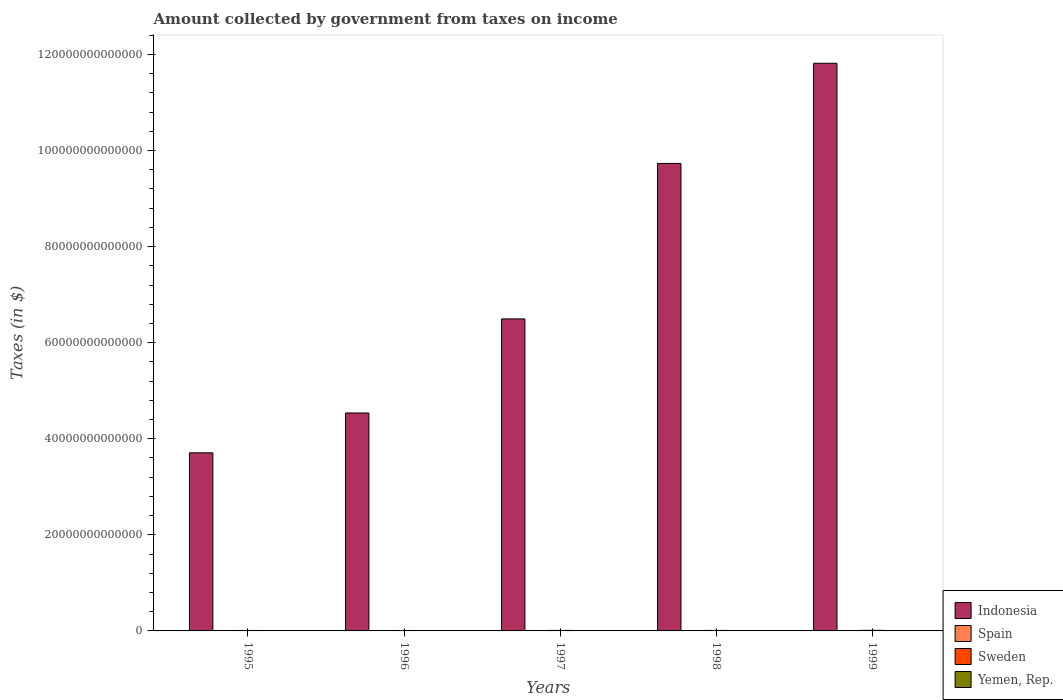How many different coloured bars are there?
Offer a very short reply. 4. Are the number of bars per tick equal to the number of legend labels?
Provide a succinct answer. Yes. In how many cases, is the number of bars for a given year not equal to the number of legend labels?
Give a very brief answer. 0. What is the amount collected by government from taxes on income in Sweden in 1997?
Offer a terse response. 1.04e+11. Across all years, what is the maximum amount collected by government from taxes on income in Indonesia?
Make the answer very short. 1.18e+14. Across all years, what is the minimum amount collected by government from taxes on income in Sweden?
Provide a short and direct response. 8.81e+1. In which year was the amount collected by government from taxes on income in Yemen, Rep. maximum?
Offer a terse response. 1998. What is the total amount collected by government from taxes on income in Sweden in the graph?
Keep it short and to the point. 5.17e+11. What is the difference between the amount collected by government from taxes on income in Indonesia in 1996 and that in 1999?
Give a very brief answer. -7.28e+13. What is the difference between the amount collected by government from taxes on income in Indonesia in 1998 and the amount collected by government from taxes on income in Sweden in 1996?
Your answer should be very brief. 9.72e+13. What is the average amount collected by government from taxes on income in Spain per year?
Keep it short and to the point. 4.33e+1. In the year 1999, what is the difference between the amount collected by government from taxes on income in Sweden and amount collected by government from taxes on income in Yemen, Rep.?
Ensure brevity in your answer.  7.61e+1. In how many years, is the amount collected by government from taxes on income in Spain greater than 120000000000000 $?
Offer a terse response. 0. What is the ratio of the amount collected by government from taxes on income in Indonesia in 1995 to that in 1998?
Make the answer very short. 0.38. Is the amount collected by government from taxes on income in Spain in 1995 less than that in 1997?
Offer a terse response. Yes. Is the difference between the amount collected by government from taxes on income in Sweden in 1995 and 1999 greater than the difference between the amount collected by government from taxes on income in Yemen, Rep. in 1995 and 1999?
Provide a succinct answer. Yes. What is the difference between the highest and the second highest amount collected by government from taxes on income in Indonesia?
Offer a terse response. 2.09e+13. What is the difference between the highest and the lowest amount collected by government from taxes on income in Indonesia?
Ensure brevity in your answer.  8.11e+13. Is it the case that in every year, the sum of the amount collected by government from taxes on income in Yemen, Rep. and amount collected by government from taxes on income in Sweden is greater than the sum of amount collected by government from taxes on income in Indonesia and amount collected by government from taxes on income in Spain?
Provide a succinct answer. Yes. What does the 1st bar from the left in 1997 represents?
Ensure brevity in your answer.  Indonesia. What does the 3rd bar from the right in 1995 represents?
Give a very brief answer. Spain. Is it the case that in every year, the sum of the amount collected by government from taxes on income in Indonesia and amount collected by government from taxes on income in Sweden is greater than the amount collected by government from taxes on income in Yemen, Rep.?
Keep it short and to the point. Yes. How many years are there in the graph?
Provide a short and direct response. 5. What is the difference between two consecutive major ticks on the Y-axis?
Provide a short and direct response. 2.00e+13. Are the values on the major ticks of Y-axis written in scientific E-notation?
Your answer should be compact. No. Does the graph contain any zero values?
Your answer should be very brief. No. Does the graph contain grids?
Ensure brevity in your answer.  No. Where does the legend appear in the graph?
Offer a terse response. Bottom right. How are the legend labels stacked?
Ensure brevity in your answer.  Vertical. What is the title of the graph?
Provide a short and direct response. Amount collected by government from taxes on income. Does "Puerto Rico" appear as one of the legend labels in the graph?
Your response must be concise. No. What is the label or title of the X-axis?
Make the answer very short. Years. What is the label or title of the Y-axis?
Give a very brief answer. Taxes (in $). What is the Taxes (in $) of Indonesia in 1995?
Your response must be concise. 3.71e+13. What is the Taxes (in $) in Spain in 1995?
Make the answer very short. 3.98e+1. What is the Taxes (in $) in Sweden in 1995?
Offer a terse response. 9.24e+1. What is the Taxes (in $) of Yemen, Rep. in 1995?
Offer a very short reply. 1.56e+1. What is the Taxes (in $) in Indonesia in 1996?
Offer a terse response. 4.54e+13. What is the Taxes (in $) of Spain in 1996?
Give a very brief answer. 4.36e+1. What is the Taxes (in $) in Sweden in 1996?
Your answer should be very brief. 8.81e+1. What is the Taxes (in $) of Yemen, Rep. in 1996?
Keep it short and to the point. 3.53e+1. What is the Taxes (in $) of Indonesia in 1997?
Keep it short and to the point. 6.49e+13. What is the Taxes (in $) of Spain in 1997?
Give a very brief answer. 4.23e+1. What is the Taxes (in $) of Sweden in 1997?
Provide a short and direct response. 1.04e+11. What is the Taxes (in $) in Yemen, Rep. in 1997?
Your answer should be very brief. 4.56e+1. What is the Taxes (in $) of Indonesia in 1998?
Keep it short and to the point. 9.73e+13. What is the Taxes (in $) of Spain in 1998?
Offer a terse response. 4.42e+1. What is the Taxes (in $) in Sweden in 1998?
Your answer should be very brief. 1.06e+11. What is the Taxes (in $) in Yemen, Rep. in 1998?
Give a very brief answer. 5.44e+1. What is the Taxes (in $) in Indonesia in 1999?
Offer a terse response. 1.18e+14. What is the Taxes (in $) of Spain in 1999?
Provide a short and direct response. 4.67e+1. What is the Taxes (in $) of Sweden in 1999?
Make the answer very short. 1.26e+11. What is the Taxes (in $) of Yemen, Rep. in 1999?
Offer a terse response. 5.02e+1. Across all years, what is the maximum Taxes (in $) of Indonesia?
Your answer should be very brief. 1.18e+14. Across all years, what is the maximum Taxes (in $) in Spain?
Your answer should be compact. 4.67e+1. Across all years, what is the maximum Taxes (in $) in Sweden?
Give a very brief answer. 1.26e+11. Across all years, what is the maximum Taxes (in $) in Yemen, Rep.?
Your response must be concise. 5.44e+1. Across all years, what is the minimum Taxes (in $) of Indonesia?
Your response must be concise. 3.71e+13. Across all years, what is the minimum Taxes (in $) of Spain?
Ensure brevity in your answer.  3.98e+1. Across all years, what is the minimum Taxes (in $) in Sweden?
Offer a very short reply. 8.81e+1. Across all years, what is the minimum Taxes (in $) in Yemen, Rep.?
Provide a succinct answer. 1.56e+1. What is the total Taxes (in $) in Indonesia in the graph?
Provide a short and direct response. 3.63e+14. What is the total Taxes (in $) in Spain in the graph?
Provide a succinct answer. 2.17e+11. What is the total Taxes (in $) in Sweden in the graph?
Your response must be concise. 5.17e+11. What is the total Taxes (in $) of Yemen, Rep. in the graph?
Your response must be concise. 2.01e+11. What is the difference between the Taxes (in $) of Indonesia in 1995 and that in 1996?
Offer a very short reply. -8.29e+12. What is the difference between the Taxes (in $) in Spain in 1995 and that in 1996?
Make the answer very short. -3.75e+09. What is the difference between the Taxes (in $) in Sweden in 1995 and that in 1996?
Provide a succinct answer. 4.31e+09. What is the difference between the Taxes (in $) in Yemen, Rep. in 1995 and that in 1996?
Ensure brevity in your answer.  -1.97e+1. What is the difference between the Taxes (in $) of Indonesia in 1995 and that in 1997?
Make the answer very short. -2.79e+13. What is the difference between the Taxes (in $) in Spain in 1995 and that in 1997?
Give a very brief answer. -2.43e+09. What is the difference between the Taxes (in $) in Sweden in 1995 and that in 1997?
Your answer should be compact. -1.18e+1. What is the difference between the Taxes (in $) of Yemen, Rep. in 1995 and that in 1997?
Offer a very short reply. -3.00e+1. What is the difference between the Taxes (in $) of Indonesia in 1995 and that in 1998?
Offer a terse response. -6.02e+13. What is the difference between the Taxes (in $) of Spain in 1995 and that in 1998?
Offer a terse response. -4.38e+09. What is the difference between the Taxes (in $) of Sweden in 1995 and that in 1998?
Provide a succinct answer. -1.35e+1. What is the difference between the Taxes (in $) in Yemen, Rep. in 1995 and that in 1998?
Provide a succinct answer. -3.88e+1. What is the difference between the Taxes (in $) of Indonesia in 1995 and that in 1999?
Provide a succinct answer. -8.11e+13. What is the difference between the Taxes (in $) in Spain in 1995 and that in 1999?
Ensure brevity in your answer.  -6.83e+09. What is the difference between the Taxes (in $) in Sweden in 1995 and that in 1999?
Give a very brief answer. -3.40e+1. What is the difference between the Taxes (in $) in Yemen, Rep. in 1995 and that in 1999?
Your answer should be very brief. -3.46e+1. What is the difference between the Taxes (in $) of Indonesia in 1996 and that in 1997?
Your answer should be very brief. -1.96e+13. What is the difference between the Taxes (in $) of Spain in 1996 and that in 1997?
Give a very brief answer. 1.31e+09. What is the difference between the Taxes (in $) of Sweden in 1996 and that in 1997?
Your answer should be very brief. -1.61e+1. What is the difference between the Taxes (in $) of Yemen, Rep. in 1996 and that in 1997?
Offer a very short reply. -1.03e+1. What is the difference between the Taxes (in $) in Indonesia in 1996 and that in 1998?
Offer a very short reply. -5.19e+13. What is the difference between the Taxes (in $) in Spain in 1996 and that in 1998?
Your answer should be compact. -6.33e+08. What is the difference between the Taxes (in $) of Sweden in 1996 and that in 1998?
Your answer should be very brief. -1.78e+1. What is the difference between the Taxes (in $) of Yemen, Rep. in 1996 and that in 1998?
Keep it short and to the point. -1.92e+1. What is the difference between the Taxes (in $) in Indonesia in 1996 and that in 1999?
Keep it short and to the point. -7.28e+13. What is the difference between the Taxes (in $) in Spain in 1996 and that in 1999?
Keep it short and to the point. -3.08e+09. What is the difference between the Taxes (in $) in Sweden in 1996 and that in 1999?
Provide a succinct answer. -3.83e+1. What is the difference between the Taxes (in $) of Yemen, Rep. in 1996 and that in 1999?
Your response must be concise. -1.50e+1. What is the difference between the Taxes (in $) in Indonesia in 1997 and that in 1998?
Keep it short and to the point. -3.24e+13. What is the difference between the Taxes (in $) of Spain in 1997 and that in 1998?
Your answer should be very brief. -1.95e+09. What is the difference between the Taxes (in $) of Sweden in 1997 and that in 1998?
Offer a very short reply. -1.67e+09. What is the difference between the Taxes (in $) of Yemen, Rep. in 1997 and that in 1998?
Give a very brief answer. -8.85e+09. What is the difference between the Taxes (in $) of Indonesia in 1997 and that in 1999?
Provide a succinct answer. -5.32e+13. What is the difference between the Taxes (in $) in Spain in 1997 and that in 1999?
Provide a short and direct response. -4.40e+09. What is the difference between the Taxes (in $) in Sweden in 1997 and that in 1999?
Keep it short and to the point. -2.21e+1. What is the difference between the Taxes (in $) of Yemen, Rep. in 1997 and that in 1999?
Offer a very short reply. -4.65e+09. What is the difference between the Taxes (in $) of Indonesia in 1998 and that in 1999?
Offer a very short reply. -2.09e+13. What is the difference between the Taxes (in $) of Spain in 1998 and that in 1999?
Offer a terse response. -2.45e+09. What is the difference between the Taxes (in $) of Sweden in 1998 and that in 1999?
Offer a terse response. -2.05e+1. What is the difference between the Taxes (in $) in Yemen, Rep. in 1998 and that in 1999?
Provide a short and direct response. 4.20e+09. What is the difference between the Taxes (in $) in Indonesia in 1995 and the Taxes (in $) in Spain in 1996?
Offer a very short reply. 3.70e+13. What is the difference between the Taxes (in $) in Indonesia in 1995 and the Taxes (in $) in Sweden in 1996?
Offer a terse response. 3.70e+13. What is the difference between the Taxes (in $) of Indonesia in 1995 and the Taxes (in $) of Yemen, Rep. in 1996?
Your answer should be compact. 3.70e+13. What is the difference between the Taxes (in $) of Spain in 1995 and the Taxes (in $) of Sweden in 1996?
Make the answer very short. -4.83e+1. What is the difference between the Taxes (in $) of Spain in 1995 and the Taxes (in $) of Yemen, Rep. in 1996?
Keep it short and to the point. 4.55e+09. What is the difference between the Taxes (in $) of Sweden in 1995 and the Taxes (in $) of Yemen, Rep. in 1996?
Give a very brief answer. 5.71e+1. What is the difference between the Taxes (in $) in Indonesia in 1995 and the Taxes (in $) in Spain in 1997?
Offer a very short reply. 3.70e+13. What is the difference between the Taxes (in $) in Indonesia in 1995 and the Taxes (in $) in Sweden in 1997?
Your answer should be very brief. 3.70e+13. What is the difference between the Taxes (in $) in Indonesia in 1995 and the Taxes (in $) in Yemen, Rep. in 1997?
Offer a very short reply. 3.70e+13. What is the difference between the Taxes (in $) of Spain in 1995 and the Taxes (in $) of Sweden in 1997?
Ensure brevity in your answer.  -6.44e+1. What is the difference between the Taxes (in $) in Spain in 1995 and the Taxes (in $) in Yemen, Rep. in 1997?
Your answer should be very brief. -5.76e+09. What is the difference between the Taxes (in $) in Sweden in 1995 and the Taxes (in $) in Yemen, Rep. in 1997?
Make the answer very short. 4.68e+1. What is the difference between the Taxes (in $) in Indonesia in 1995 and the Taxes (in $) in Spain in 1998?
Give a very brief answer. 3.70e+13. What is the difference between the Taxes (in $) in Indonesia in 1995 and the Taxes (in $) in Sweden in 1998?
Provide a succinct answer. 3.70e+13. What is the difference between the Taxes (in $) of Indonesia in 1995 and the Taxes (in $) of Yemen, Rep. in 1998?
Your answer should be very brief. 3.70e+13. What is the difference between the Taxes (in $) of Spain in 1995 and the Taxes (in $) of Sweden in 1998?
Provide a short and direct response. -6.61e+1. What is the difference between the Taxes (in $) of Spain in 1995 and the Taxes (in $) of Yemen, Rep. in 1998?
Your answer should be very brief. -1.46e+1. What is the difference between the Taxes (in $) of Sweden in 1995 and the Taxes (in $) of Yemen, Rep. in 1998?
Your answer should be compact. 3.80e+1. What is the difference between the Taxes (in $) in Indonesia in 1995 and the Taxes (in $) in Spain in 1999?
Make the answer very short. 3.70e+13. What is the difference between the Taxes (in $) of Indonesia in 1995 and the Taxes (in $) of Sweden in 1999?
Provide a succinct answer. 3.69e+13. What is the difference between the Taxes (in $) in Indonesia in 1995 and the Taxes (in $) in Yemen, Rep. in 1999?
Provide a succinct answer. 3.70e+13. What is the difference between the Taxes (in $) of Spain in 1995 and the Taxes (in $) of Sweden in 1999?
Your response must be concise. -8.65e+1. What is the difference between the Taxes (in $) in Spain in 1995 and the Taxes (in $) in Yemen, Rep. in 1999?
Ensure brevity in your answer.  -1.04e+1. What is the difference between the Taxes (in $) in Sweden in 1995 and the Taxes (in $) in Yemen, Rep. in 1999?
Offer a very short reply. 4.22e+1. What is the difference between the Taxes (in $) of Indonesia in 1996 and the Taxes (in $) of Spain in 1997?
Your answer should be very brief. 4.53e+13. What is the difference between the Taxes (in $) in Indonesia in 1996 and the Taxes (in $) in Sweden in 1997?
Your answer should be very brief. 4.53e+13. What is the difference between the Taxes (in $) of Indonesia in 1996 and the Taxes (in $) of Yemen, Rep. in 1997?
Provide a succinct answer. 4.53e+13. What is the difference between the Taxes (in $) of Spain in 1996 and the Taxes (in $) of Sweden in 1997?
Ensure brevity in your answer.  -6.07e+1. What is the difference between the Taxes (in $) of Spain in 1996 and the Taxes (in $) of Yemen, Rep. in 1997?
Offer a very short reply. -2.01e+09. What is the difference between the Taxes (in $) in Sweden in 1996 and the Taxes (in $) in Yemen, Rep. in 1997?
Your answer should be compact. 4.25e+1. What is the difference between the Taxes (in $) in Indonesia in 1996 and the Taxes (in $) in Spain in 1998?
Your response must be concise. 4.53e+13. What is the difference between the Taxes (in $) of Indonesia in 1996 and the Taxes (in $) of Sweden in 1998?
Give a very brief answer. 4.53e+13. What is the difference between the Taxes (in $) in Indonesia in 1996 and the Taxes (in $) in Yemen, Rep. in 1998?
Provide a short and direct response. 4.53e+13. What is the difference between the Taxes (in $) in Spain in 1996 and the Taxes (in $) in Sweden in 1998?
Keep it short and to the point. -6.23e+1. What is the difference between the Taxes (in $) of Spain in 1996 and the Taxes (in $) of Yemen, Rep. in 1998?
Your answer should be compact. -1.09e+1. What is the difference between the Taxes (in $) of Sweden in 1996 and the Taxes (in $) of Yemen, Rep. in 1998?
Offer a terse response. 3.37e+1. What is the difference between the Taxes (in $) in Indonesia in 1996 and the Taxes (in $) in Spain in 1999?
Your answer should be compact. 4.53e+13. What is the difference between the Taxes (in $) of Indonesia in 1996 and the Taxes (in $) of Sweden in 1999?
Provide a succinct answer. 4.52e+13. What is the difference between the Taxes (in $) in Indonesia in 1996 and the Taxes (in $) in Yemen, Rep. in 1999?
Give a very brief answer. 4.53e+13. What is the difference between the Taxes (in $) in Spain in 1996 and the Taxes (in $) in Sweden in 1999?
Provide a short and direct response. -8.28e+1. What is the difference between the Taxes (in $) in Spain in 1996 and the Taxes (in $) in Yemen, Rep. in 1999?
Give a very brief answer. -6.66e+09. What is the difference between the Taxes (in $) of Sweden in 1996 and the Taxes (in $) of Yemen, Rep. in 1999?
Your answer should be compact. 3.79e+1. What is the difference between the Taxes (in $) in Indonesia in 1997 and the Taxes (in $) in Spain in 1998?
Your answer should be compact. 6.49e+13. What is the difference between the Taxes (in $) of Indonesia in 1997 and the Taxes (in $) of Sweden in 1998?
Make the answer very short. 6.48e+13. What is the difference between the Taxes (in $) of Indonesia in 1997 and the Taxes (in $) of Yemen, Rep. in 1998?
Offer a terse response. 6.49e+13. What is the difference between the Taxes (in $) of Spain in 1997 and the Taxes (in $) of Sweden in 1998?
Provide a short and direct response. -6.36e+1. What is the difference between the Taxes (in $) in Spain in 1997 and the Taxes (in $) in Yemen, Rep. in 1998?
Your answer should be very brief. -1.22e+1. What is the difference between the Taxes (in $) of Sweden in 1997 and the Taxes (in $) of Yemen, Rep. in 1998?
Give a very brief answer. 4.98e+1. What is the difference between the Taxes (in $) of Indonesia in 1997 and the Taxes (in $) of Spain in 1999?
Your answer should be very brief. 6.49e+13. What is the difference between the Taxes (in $) in Indonesia in 1997 and the Taxes (in $) in Sweden in 1999?
Provide a succinct answer. 6.48e+13. What is the difference between the Taxes (in $) of Indonesia in 1997 and the Taxes (in $) of Yemen, Rep. in 1999?
Offer a terse response. 6.49e+13. What is the difference between the Taxes (in $) of Spain in 1997 and the Taxes (in $) of Sweden in 1999?
Provide a short and direct response. -8.41e+1. What is the difference between the Taxes (in $) in Spain in 1997 and the Taxes (in $) in Yemen, Rep. in 1999?
Your response must be concise. -7.98e+09. What is the difference between the Taxes (in $) in Sweden in 1997 and the Taxes (in $) in Yemen, Rep. in 1999?
Keep it short and to the point. 5.40e+1. What is the difference between the Taxes (in $) in Indonesia in 1998 and the Taxes (in $) in Spain in 1999?
Keep it short and to the point. 9.73e+13. What is the difference between the Taxes (in $) of Indonesia in 1998 and the Taxes (in $) of Sweden in 1999?
Provide a short and direct response. 9.72e+13. What is the difference between the Taxes (in $) of Indonesia in 1998 and the Taxes (in $) of Yemen, Rep. in 1999?
Your answer should be very brief. 9.73e+13. What is the difference between the Taxes (in $) in Spain in 1998 and the Taxes (in $) in Sweden in 1999?
Provide a succinct answer. -8.22e+1. What is the difference between the Taxes (in $) in Spain in 1998 and the Taxes (in $) in Yemen, Rep. in 1999?
Offer a terse response. -6.03e+09. What is the difference between the Taxes (in $) in Sweden in 1998 and the Taxes (in $) in Yemen, Rep. in 1999?
Your response must be concise. 5.57e+1. What is the average Taxes (in $) of Indonesia per year?
Your response must be concise. 7.26e+13. What is the average Taxes (in $) of Spain per year?
Offer a terse response. 4.33e+1. What is the average Taxes (in $) in Sweden per year?
Your answer should be very brief. 1.03e+11. What is the average Taxes (in $) in Yemen, Rep. per year?
Ensure brevity in your answer.  4.02e+1. In the year 1995, what is the difference between the Taxes (in $) in Indonesia and Taxes (in $) in Spain?
Offer a terse response. 3.70e+13. In the year 1995, what is the difference between the Taxes (in $) in Indonesia and Taxes (in $) in Sweden?
Your answer should be very brief. 3.70e+13. In the year 1995, what is the difference between the Taxes (in $) of Indonesia and Taxes (in $) of Yemen, Rep.?
Ensure brevity in your answer.  3.71e+13. In the year 1995, what is the difference between the Taxes (in $) in Spain and Taxes (in $) in Sweden?
Give a very brief answer. -5.26e+1. In the year 1995, what is the difference between the Taxes (in $) of Spain and Taxes (in $) of Yemen, Rep.?
Provide a short and direct response. 2.42e+1. In the year 1995, what is the difference between the Taxes (in $) in Sweden and Taxes (in $) in Yemen, Rep.?
Your answer should be very brief. 7.68e+1. In the year 1996, what is the difference between the Taxes (in $) in Indonesia and Taxes (in $) in Spain?
Your answer should be very brief. 4.53e+13. In the year 1996, what is the difference between the Taxes (in $) of Indonesia and Taxes (in $) of Sweden?
Offer a terse response. 4.53e+13. In the year 1996, what is the difference between the Taxes (in $) of Indonesia and Taxes (in $) of Yemen, Rep.?
Offer a terse response. 4.53e+13. In the year 1996, what is the difference between the Taxes (in $) of Spain and Taxes (in $) of Sweden?
Give a very brief answer. -4.45e+1. In the year 1996, what is the difference between the Taxes (in $) of Spain and Taxes (in $) of Yemen, Rep.?
Provide a short and direct response. 8.30e+09. In the year 1996, what is the difference between the Taxes (in $) in Sweden and Taxes (in $) in Yemen, Rep.?
Your response must be concise. 5.28e+1. In the year 1997, what is the difference between the Taxes (in $) in Indonesia and Taxes (in $) in Spain?
Ensure brevity in your answer.  6.49e+13. In the year 1997, what is the difference between the Taxes (in $) of Indonesia and Taxes (in $) of Sweden?
Your answer should be compact. 6.48e+13. In the year 1997, what is the difference between the Taxes (in $) in Indonesia and Taxes (in $) in Yemen, Rep.?
Give a very brief answer. 6.49e+13. In the year 1997, what is the difference between the Taxes (in $) in Spain and Taxes (in $) in Sweden?
Ensure brevity in your answer.  -6.20e+1. In the year 1997, what is the difference between the Taxes (in $) of Spain and Taxes (in $) of Yemen, Rep.?
Your answer should be compact. -3.32e+09. In the year 1997, what is the difference between the Taxes (in $) in Sweden and Taxes (in $) in Yemen, Rep.?
Give a very brief answer. 5.86e+1. In the year 1998, what is the difference between the Taxes (in $) in Indonesia and Taxes (in $) in Spain?
Offer a terse response. 9.73e+13. In the year 1998, what is the difference between the Taxes (in $) in Indonesia and Taxes (in $) in Sweden?
Ensure brevity in your answer.  9.72e+13. In the year 1998, what is the difference between the Taxes (in $) of Indonesia and Taxes (in $) of Yemen, Rep.?
Keep it short and to the point. 9.73e+13. In the year 1998, what is the difference between the Taxes (in $) of Spain and Taxes (in $) of Sweden?
Keep it short and to the point. -6.17e+1. In the year 1998, what is the difference between the Taxes (in $) of Spain and Taxes (in $) of Yemen, Rep.?
Offer a very short reply. -1.02e+1. In the year 1998, what is the difference between the Taxes (in $) of Sweden and Taxes (in $) of Yemen, Rep.?
Offer a terse response. 5.15e+1. In the year 1999, what is the difference between the Taxes (in $) of Indonesia and Taxes (in $) of Spain?
Offer a very short reply. 1.18e+14. In the year 1999, what is the difference between the Taxes (in $) of Indonesia and Taxes (in $) of Sweden?
Give a very brief answer. 1.18e+14. In the year 1999, what is the difference between the Taxes (in $) of Indonesia and Taxes (in $) of Yemen, Rep.?
Keep it short and to the point. 1.18e+14. In the year 1999, what is the difference between the Taxes (in $) of Spain and Taxes (in $) of Sweden?
Provide a succinct answer. -7.97e+1. In the year 1999, what is the difference between the Taxes (in $) of Spain and Taxes (in $) of Yemen, Rep.?
Offer a very short reply. -3.58e+09. In the year 1999, what is the difference between the Taxes (in $) in Sweden and Taxes (in $) in Yemen, Rep.?
Provide a succinct answer. 7.61e+1. What is the ratio of the Taxes (in $) in Indonesia in 1995 to that in 1996?
Keep it short and to the point. 0.82. What is the ratio of the Taxes (in $) in Spain in 1995 to that in 1996?
Give a very brief answer. 0.91. What is the ratio of the Taxes (in $) in Sweden in 1995 to that in 1996?
Offer a terse response. 1.05. What is the ratio of the Taxes (in $) in Yemen, Rep. in 1995 to that in 1996?
Offer a terse response. 0.44. What is the ratio of the Taxes (in $) of Indonesia in 1995 to that in 1997?
Make the answer very short. 0.57. What is the ratio of the Taxes (in $) of Spain in 1995 to that in 1997?
Provide a succinct answer. 0.94. What is the ratio of the Taxes (in $) of Sweden in 1995 to that in 1997?
Make the answer very short. 0.89. What is the ratio of the Taxes (in $) of Yemen, Rep. in 1995 to that in 1997?
Keep it short and to the point. 0.34. What is the ratio of the Taxes (in $) of Indonesia in 1995 to that in 1998?
Keep it short and to the point. 0.38. What is the ratio of the Taxes (in $) of Spain in 1995 to that in 1998?
Give a very brief answer. 0.9. What is the ratio of the Taxes (in $) of Sweden in 1995 to that in 1998?
Give a very brief answer. 0.87. What is the ratio of the Taxes (in $) of Yemen, Rep. in 1995 to that in 1998?
Your answer should be compact. 0.29. What is the ratio of the Taxes (in $) in Indonesia in 1995 to that in 1999?
Ensure brevity in your answer.  0.31. What is the ratio of the Taxes (in $) in Spain in 1995 to that in 1999?
Your answer should be very brief. 0.85. What is the ratio of the Taxes (in $) of Sweden in 1995 to that in 1999?
Provide a short and direct response. 0.73. What is the ratio of the Taxes (in $) in Yemen, Rep. in 1995 to that in 1999?
Make the answer very short. 0.31. What is the ratio of the Taxes (in $) in Indonesia in 1996 to that in 1997?
Ensure brevity in your answer.  0.7. What is the ratio of the Taxes (in $) of Spain in 1996 to that in 1997?
Offer a terse response. 1.03. What is the ratio of the Taxes (in $) of Sweden in 1996 to that in 1997?
Keep it short and to the point. 0.85. What is the ratio of the Taxes (in $) of Yemen, Rep. in 1996 to that in 1997?
Provide a short and direct response. 0.77. What is the ratio of the Taxes (in $) in Indonesia in 1996 to that in 1998?
Keep it short and to the point. 0.47. What is the ratio of the Taxes (in $) of Spain in 1996 to that in 1998?
Your answer should be very brief. 0.99. What is the ratio of the Taxes (in $) in Sweden in 1996 to that in 1998?
Ensure brevity in your answer.  0.83. What is the ratio of the Taxes (in $) in Yemen, Rep. in 1996 to that in 1998?
Offer a terse response. 0.65. What is the ratio of the Taxes (in $) of Indonesia in 1996 to that in 1999?
Offer a very short reply. 0.38. What is the ratio of the Taxes (in $) in Spain in 1996 to that in 1999?
Offer a terse response. 0.93. What is the ratio of the Taxes (in $) of Sweden in 1996 to that in 1999?
Give a very brief answer. 0.7. What is the ratio of the Taxes (in $) of Yemen, Rep. in 1996 to that in 1999?
Your answer should be compact. 0.7. What is the ratio of the Taxes (in $) in Indonesia in 1997 to that in 1998?
Your answer should be compact. 0.67. What is the ratio of the Taxes (in $) in Spain in 1997 to that in 1998?
Ensure brevity in your answer.  0.96. What is the ratio of the Taxes (in $) of Sweden in 1997 to that in 1998?
Your answer should be very brief. 0.98. What is the ratio of the Taxes (in $) of Yemen, Rep. in 1997 to that in 1998?
Your answer should be very brief. 0.84. What is the ratio of the Taxes (in $) of Indonesia in 1997 to that in 1999?
Offer a very short reply. 0.55. What is the ratio of the Taxes (in $) of Spain in 1997 to that in 1999?
Your response must be concise. 0.91. What is the ratio of the Taxes (in $) of Sweden in 1997 to that in 1999?
Ensure brevity in your answer.  0.82. What is the ratio of the Taxes (in $) of Yemen, Rep. in 1997 to that in 1999?
Your response must be concise. 0.91. What is the ratio of the Taxes (in $) of Indonesia in 1998 to that in 1999?
Make the answer very short. 0.82. What is the ratio of the Taxes (in $) in Spain in 1998 to that in 1999?
Offer a very short reply. 0.95. What is the ratio of the Taxes (in $) in Sweden in 1998 to that in 1999?
Provide a succinct answer. 0.84. What is the ratio of the Taxes (in $) in Yemen, Rep. in 1998 to that in 1999?
Offer a terse response. 1.08. What is the difference between the highest and the second highest Taxes (in $) in Indonesia?
Your response must be concise. 2.09e+13. What is the difference between the highest and the second highest Taxes (in $) in Spain?
Ensure brevity in your answer.  2.45e+09. What is the difference between the highest and the second highest Taxes (in $) of Sweden?
Your response must be concise. 2.05e+1. What is the difference between the highest and the second highest Taxes (in $) in Yemen, Rep.?
Make the answer very short. 4.20e+09. What is the difference between the highest and the lowest Taxes (in $) of Indonesia?
Make the answer very short. 8.11e+13. What is the difference between the highest and the lowest Taxes (in $) of Spain?
Your response must be concise. 6.83e+09. What is the difference between the highest and the lowest Taxes (in $) in Sweden?
Offer a very short reply. 3.83e+1. What is the difference between the highest and the lowest Taxes (in $) of Yemen, Rep.?
Provide a succinct answer. 3.88e+1. 